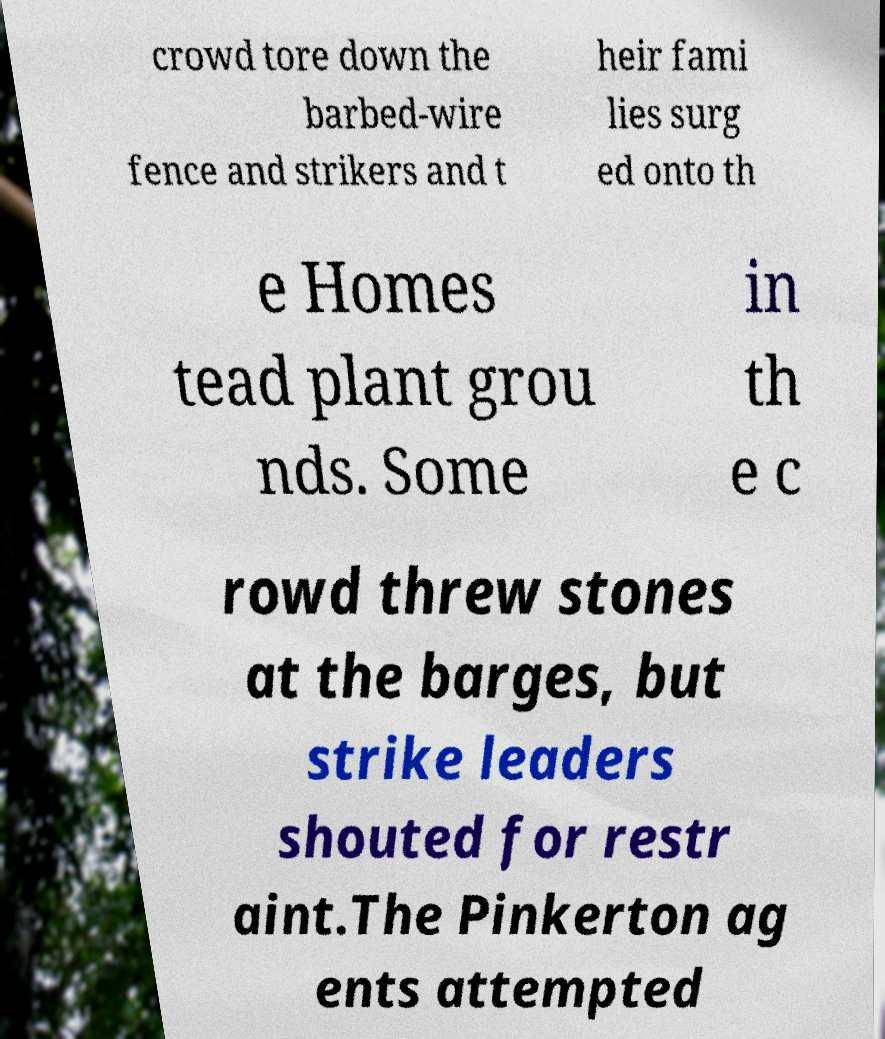Can you accurately transcribe the text from the provided image for me? crowd tore down the barbed-wire fence and strikers and t heir fami lies surg ed onto th e Homes tead plant grou nds. Some in th e c rowd threw stones at the barges, but strike leaders shouted for restr aint.The Pinkerton ag ents attempted 